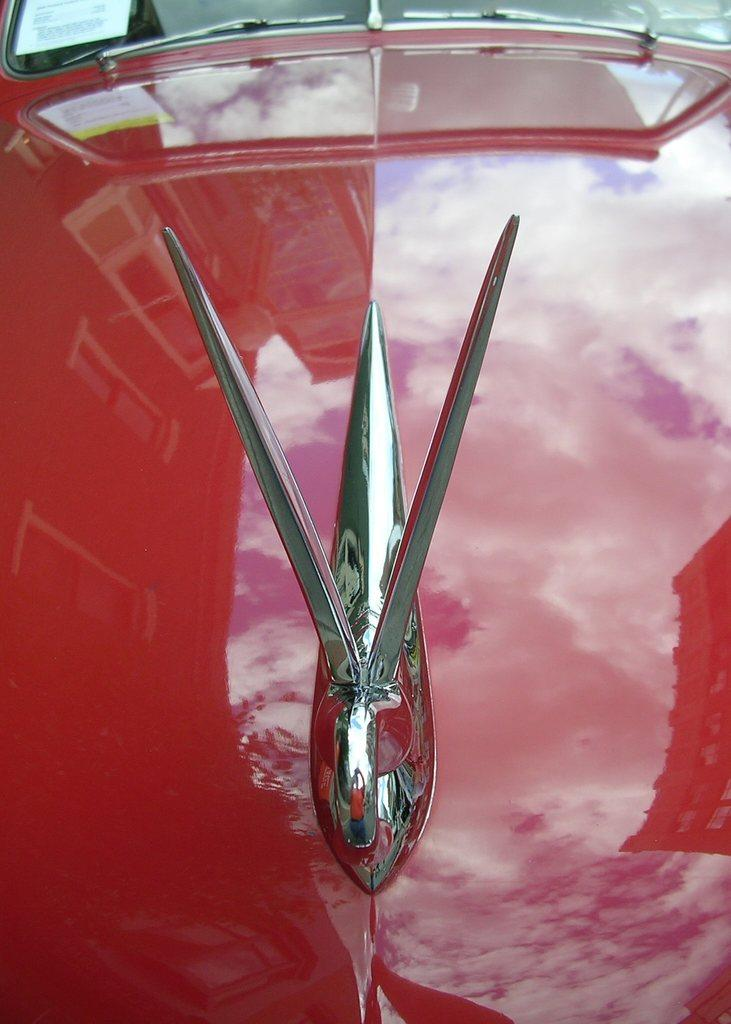What is the main subject of the image? There is a vehicle in the image. Can you describe the appearance of the vehicle? The vehicle is red in color. How many mines are visible in the image? There are no mines present in the image. Are there any men holding rifles in the image? There is no mention of men or rifles in the image, so we cannot answer this question. 